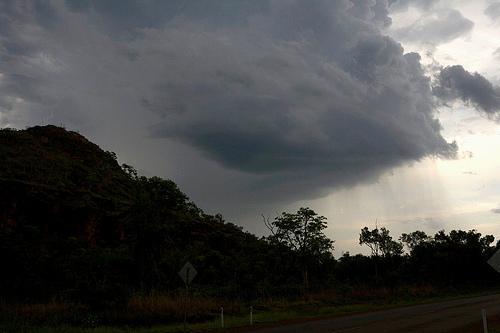How many sign boards are seen?
Give a very brief answer. 1. 